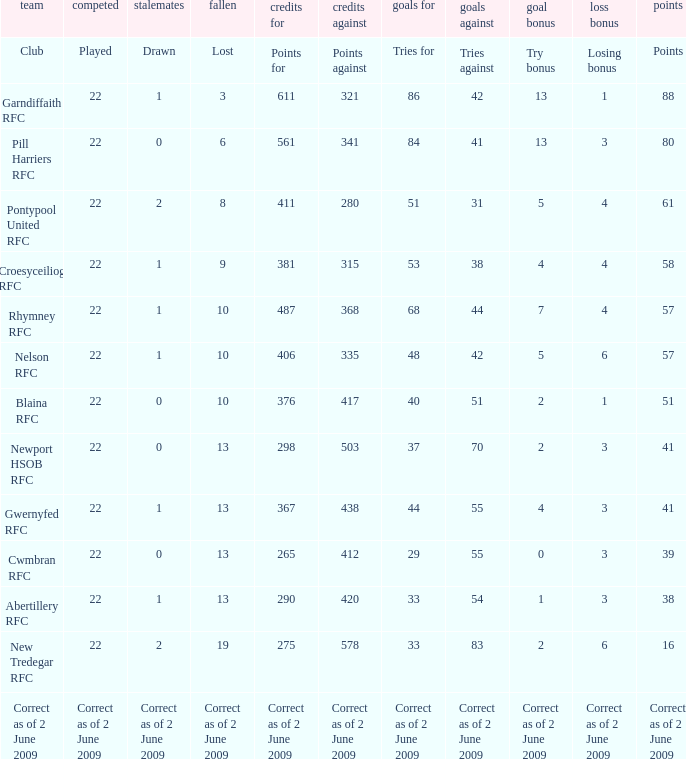Would you be able to parse every entry in this table? {'header': ['team', 'competed', 'stalemates', 'fallen', 'credits for', 'credits against', 'goals for', 'goals against', 'goal bonus', 'loss bonus', 'points'], 'rows': [['Club', 'Played', 'Drawn', 'Lost', 'Points for', 'Points against', 'Tries for', 'Tries against', 'Try bonus', 'Losing bonus', 'Points'], ['Garndiffaith RFC', '22', '1', '3', '611', '321', '86', '42', '13', '1', '88'], ['Pill Harriers RFC', '22', '0', '6', '561', '341', '84', '41', '13', '3', '80'], ['Pontypool United RFC', '22', '2', '8', '411', '280', '51', '31', '5', '4', '61'], ['Croesyceiliog RFC', '22', '1', '9', '381', '315', '53', '38', '4', '4', '58'], ['Rhymney RFC', '22', '1', '10', '487', '368', '68', '44', '7', '4', '57'], ['Nelson RFC', '22', '1', '10', '406', '335', '48', '42', '5', '6', '57'], ['Blaina RFC', '22', '0', '10', '376', '417', '40', '51', '2', '1', '51'], ['Newport HSOB RFC', '22', '0', '13', '298', '503', '37', '70', '2', '3', '41'], ['Gwernyfed RFC', '22', '1', '13', '367', '438', '44', '55', '4', '3', '41'], ['Cwmbran RFC', '22', '0', '13', '265', '412', '29', '55', '0', '3', '39'], ['Abertillery RFC', '22', '1', '13', '290', '420', '33', '54', '1', '3', '38'], ['New Tredegar RFC', '22', '2', '19', '275', '578', '33', '83', '2', '6', '16'], ['Correct as of 2 June 2009', 'Correct as of 2 June 2009', 'Correct as of 2 June 2009', 'Correct as of 2 June 2009', 'Correct as of 2 June 2009', 'Correct as of 2 June 2009', 'Correct as of 2 June 2009', 'Correct as of 2 June 2009', 'Correct as of 2 June 2009', 'Correct as of 2 June 2009', 'Correct as of 2 June 2009']]} How many tries against did the club with 1 drawn and 41 points have? 55.0. 